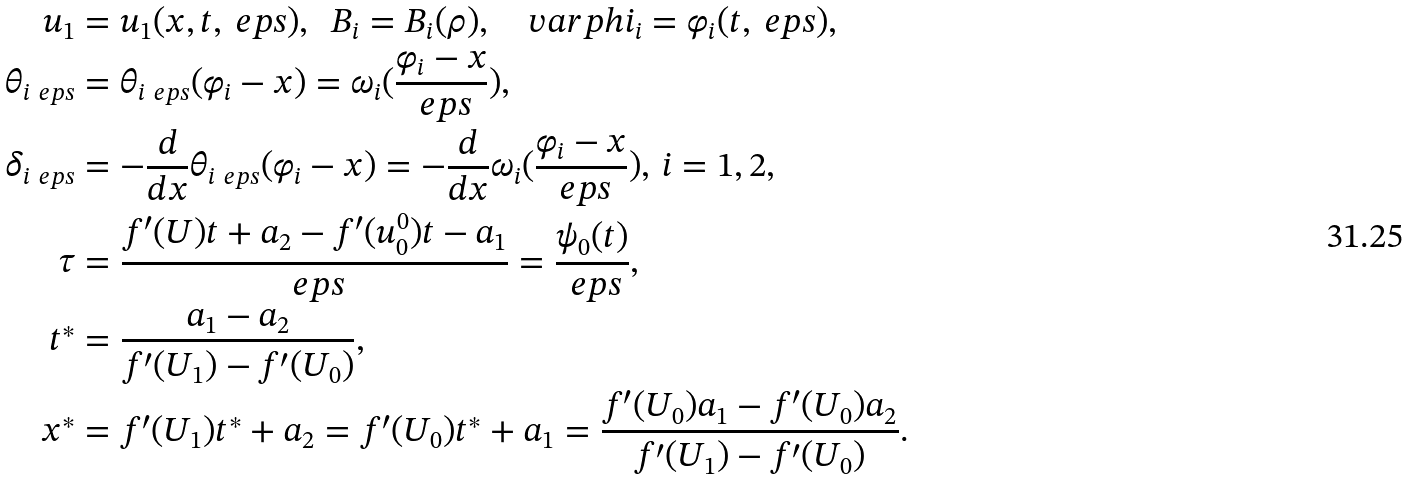<formula> <loc_0><loc_0><loc_500><loc_500>u _ { 1 } & = u _ { 1 } ( x , t , \ e p s ) , \ \ B _ { i } = B _ { i } ( \rho ) , \quad v a r p h i _ { i } = \varphi _ { i } ( t , \ e p s ) , \\ \theta _ { i \ e p s } & = \theta _ { i \ e p s } ( \varphi _ { i } - x ) = \omega _ { i } ( \frac { \varphi _ { i } - x } { \ e p s } ) , \\ \delta _ { i \ e p s } & = - \frac { d } { d x } \theta _ { i \ e p s } ( \varphi _ { i } - x ) = - \frac { d } { d x } \omega _ { i } ( \frac { \varphi _ { i } - x } { \ e p s } ) , \, i = 1 , 2 , \\ \tau & = \frac { f ^ { \prime } ( U ) t + a _ { 2 } - f ^ { \prime } ( u _ { 0 } ^ { 0 } ) t - a _ { 1 } } { \ e p s } = \frac { \psi _ { 0 } ( t ) } { \ e p s } , \\ t ^ { * } & = \frac { a _ { 1 } - a _ { 2 } } { f ^ { \prime } ( U _ { 1 } ) - f ^ { \prime } ( U _ { 0 } ) } , \\ x ^ { * } & = f ^ { \prime } ( U _ { 1 } ) t ^ { * } + a _ { 2 } = f ^ { \prime } ( U _ { 0 } ) t ^ { * } + a _ { 1 } = \frac { f ^ { \prime } ( U _ { 0 } ) a _ { 1 } - f ^ { \prime } ( U _ { 0 } ) a _ { 2 } } { f ^ { \prime } ( U _ { 1 } ) - f ^ { \prime } ( U _ { 0 } ) } .</formula> 